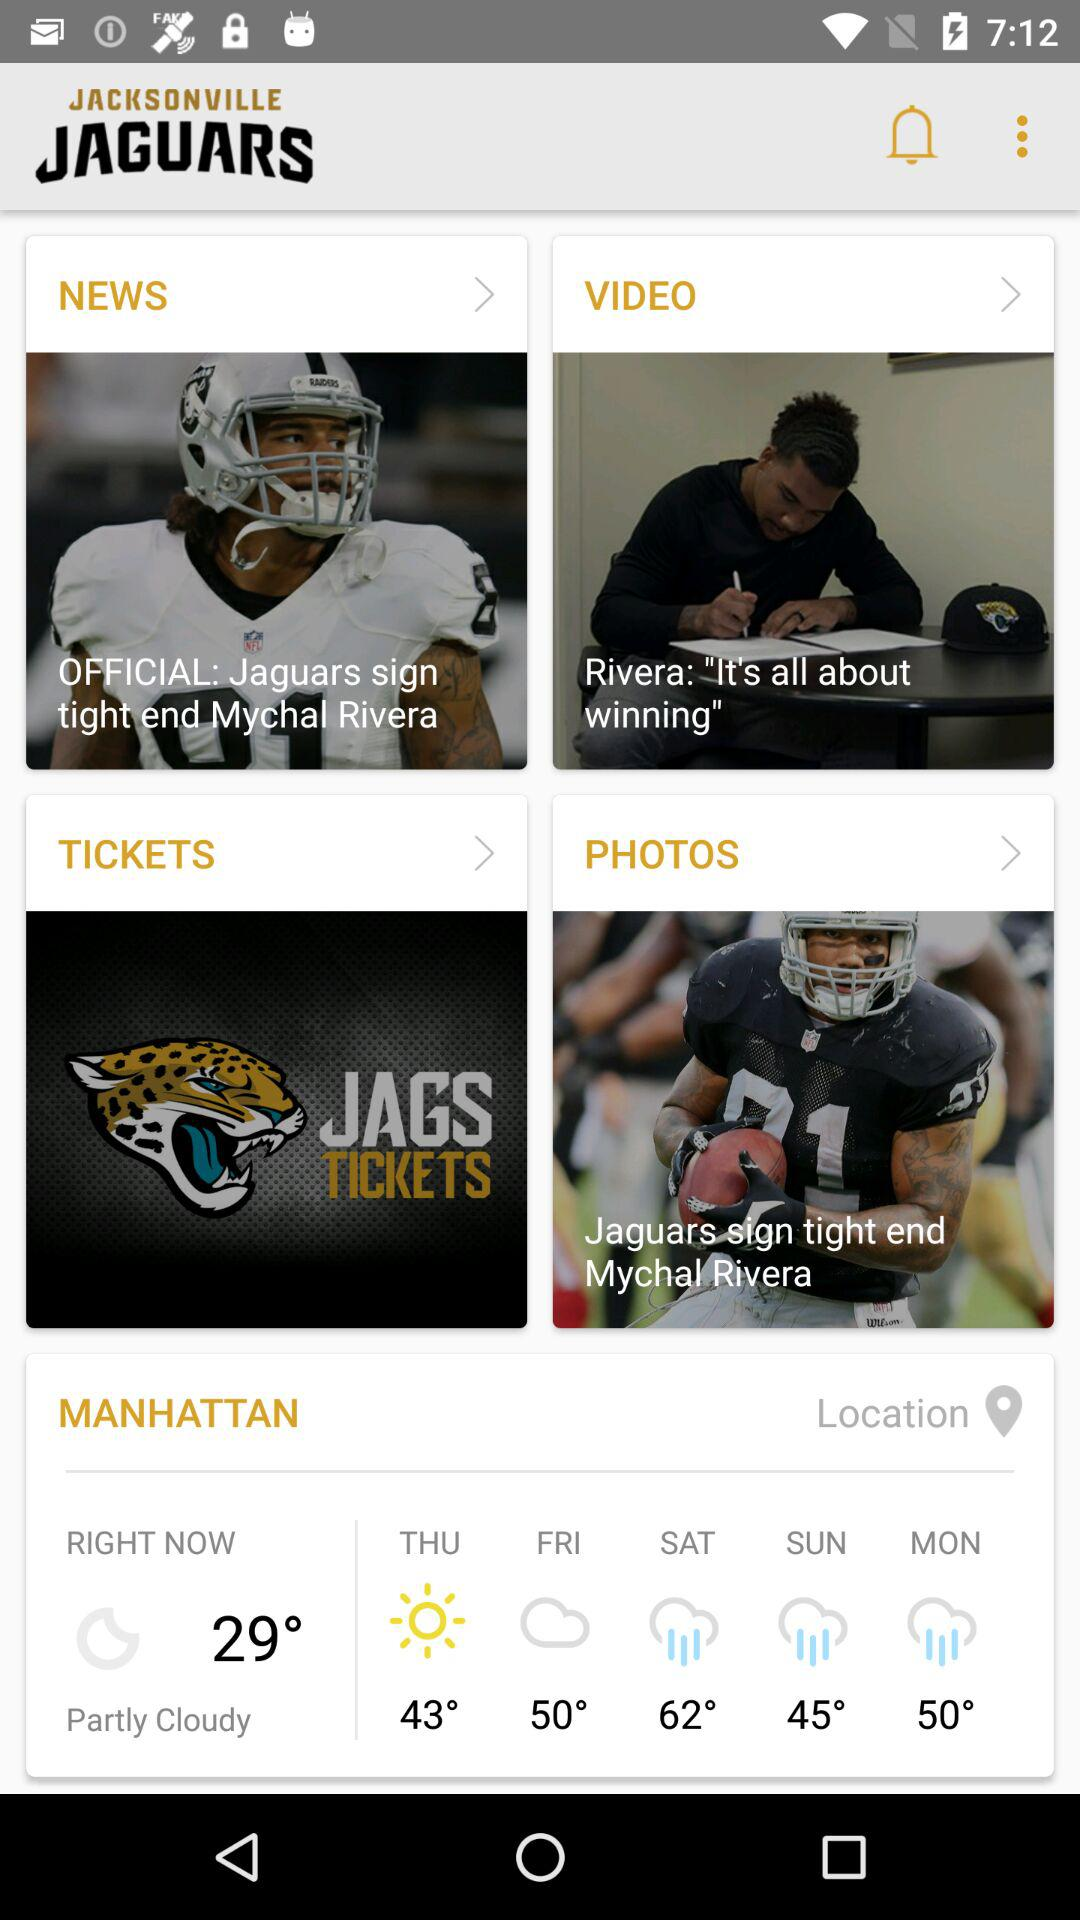Which day have maximum temperature?
When the provided information is insufficient, respond with <no answer>. <no answer> 